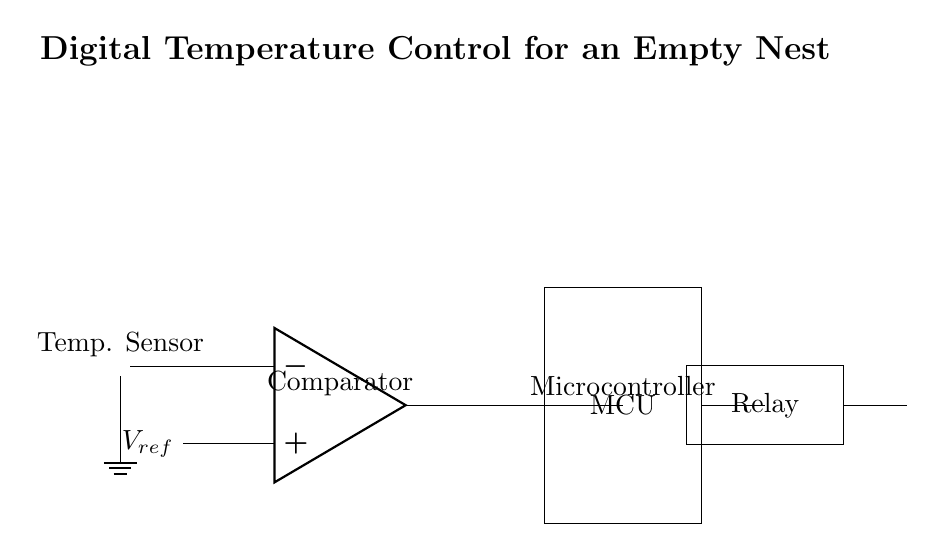What is the type of temperature sensor used in this circuit? The circuit features a thermistor as the temperature sensor, which is specifically designed to change its resistance based on the temperature.
Answer: thermistor What is the role of the microcontroller in this circuit? The microcontroller (MCU) takes the output from the comparator to control the heating element based on the temperature reading, implementing the logic necessary for maintaining temperature.
Answer: control What component converts the output signal into control action? The relay acts as a switch that turns the heater on or off based on commands it receives from the microcontroller.
Answer: relay What is connected to the positive input of the comparator? The reference voltage is connected to the positive input of the comparator, serving as the threshold against which the temperature sensor's output is compared.
Answer: V_ref What is the output of the comparator used for? The output of the comparator is used by the microcontroller to determine whether to activate the heater or not, effectively managing the temperature.
Answer: heater control How does the circuit maintain optimal warmth? The circuit maintains optimal warmth by using temperature feedback from the thermistor, which is compared to a preset reference voltage; the microcontroller then regulates the heater according to this information.
Answer: feedback control 